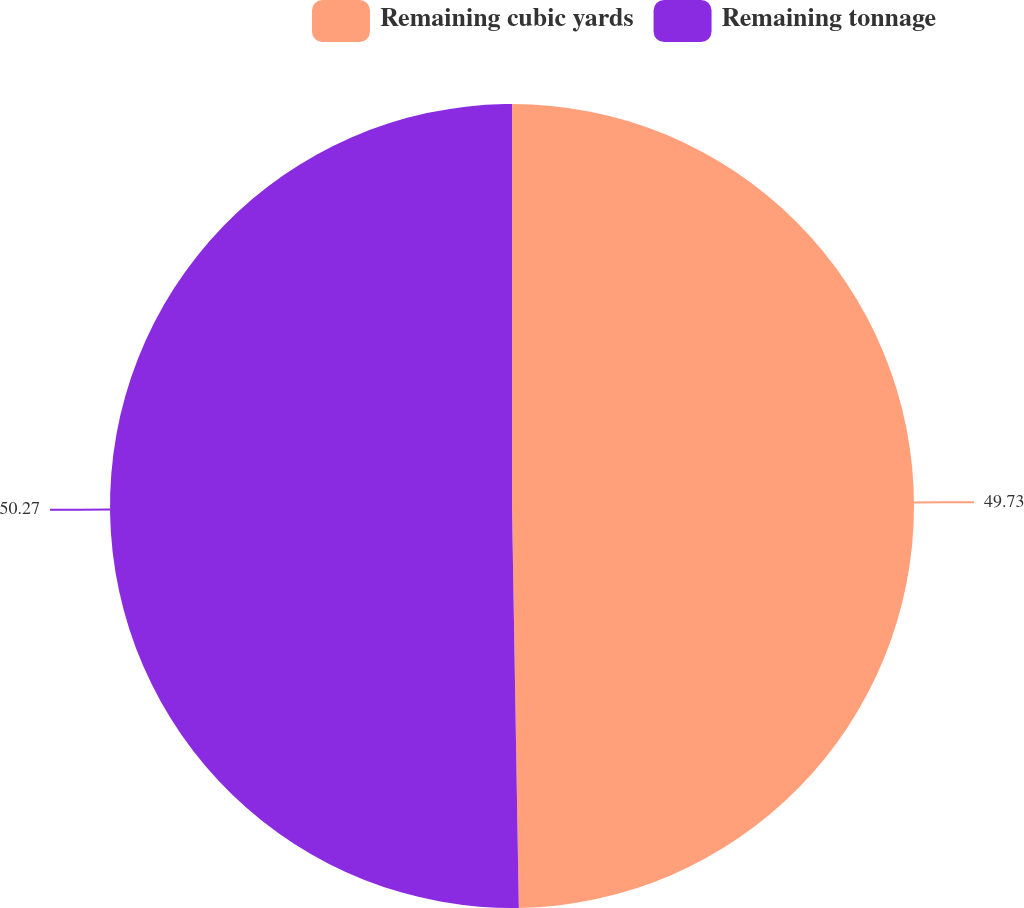Convert chart. <chart><loc_0><loc_0><loc_500><loc_500><pie_chart><fcel>Remaining cubic yards<fcel>Remaining tonnage<nl><fcel>49.73%<fcel>50.27%<nl></chart> 